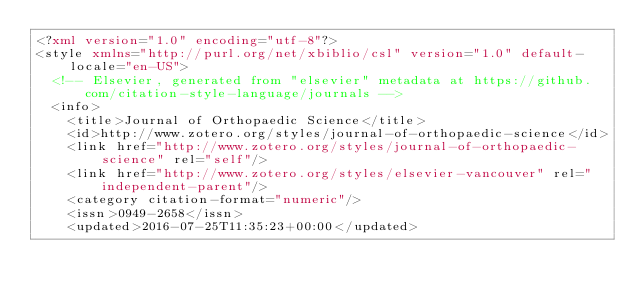<code> <loc_0><loc_0><loc_500><loc_500><_XML_><?xml version="1.0" encoding="utf-8"?>
<style xmlns="http://purl.org/net/xbiblio/csl" version="1.0" default-locale="en-US">
  <!-- Elsevier, generated from "elsevier" metadata at https://github.com/citation-style-language/journals -->
  <info>
    <title>Journal of Orthopaedic Science</title>
    <id>http://www.zotero.org/styles/journal-of-orthopaedic-science</id>
    <link href="http://www.zotero.org/styles/journal-of-orthopaedic-science" rel="self"/>
    <link href="http://www.zotero.org/styles/elsevier-vancouver" rel="independent-parent"/>
    <category citation-format="numeric"/>
    <issn>0949-2658</issn>
    <updated>2016-07-25T11:35:23+00:00</updated></code> 